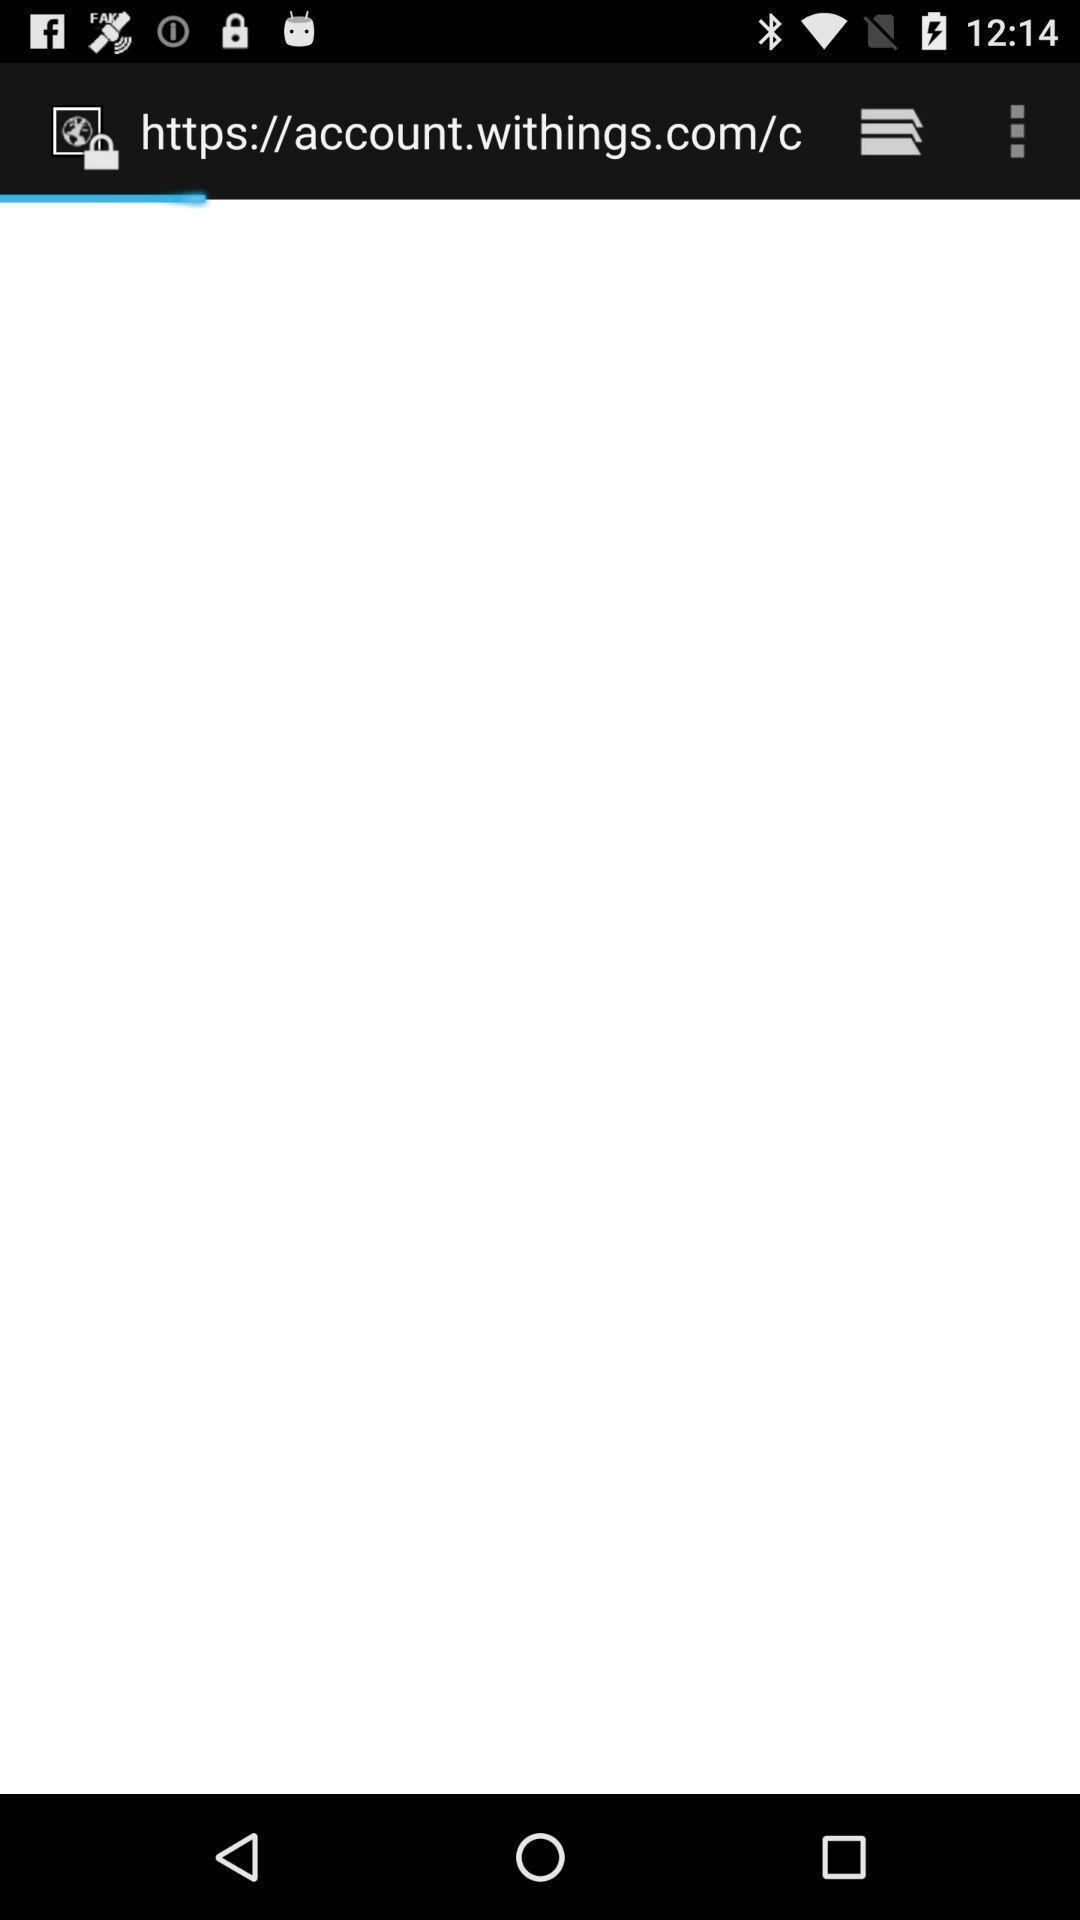Give me a summary of this screen capture. Page displaying about the website link. 